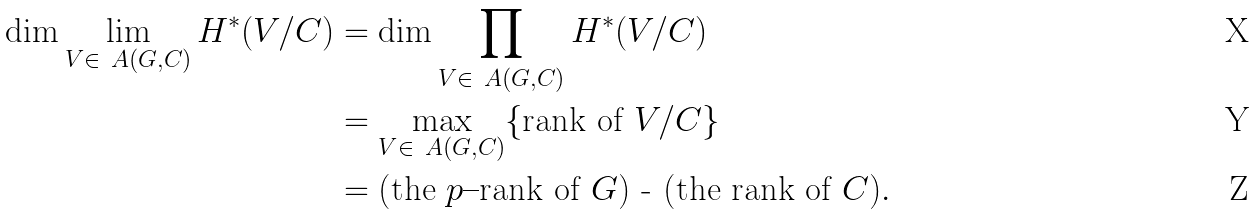Convert formula to latex. <formula><loc_0><loc_0><loc_500><loc_500>\dim \lim _ { V \in \ A ( G , C ) } H ^ { * } ( V / C ) & = \dim \prod _ { V \in \ A ( G , C ) } H ^ { * } ( V / C ) \\ & = \max _ { V \in \ A ( G , C ) } \{ \text {rank of } V / C \} \\ & = \text {(the $p$--rank of $G$) - (the rank of $C$)} .</formula> 